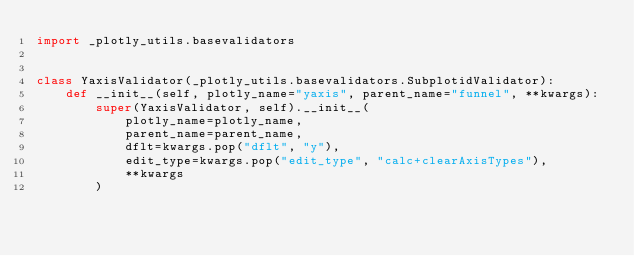Convert code to text. <code><loc_0><loc_0><loc_500><loc_500><_Python_>import _plotly_utils.basevalidators


class YaxisValidator(_plotly_utils.basevalidators.SubplotidValidator):
    def __init__(self, plotly_name="yaxis", parent_name="funnel", **kwargs):
        super(YaxisValidator, self).__init__(
            plotly_name=plotly_name,
            parent_name=parent_name,
            dflt=kwargs.pop("dflt", "y"),
            edit_type=kwargs.pop("edit_type", "calc+clearAxisTypes"),
            **kwargs
        )
</code> 